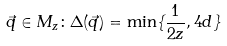Convert formula to latex. <formula><loc_0><loc_0><loc_500><loc_500>\vec { q } \in M _ { z } \colon \Delta ( \vec { q } ) = \min \{ \frac { 1 } { 2 z } , 4 d \}</formula> 